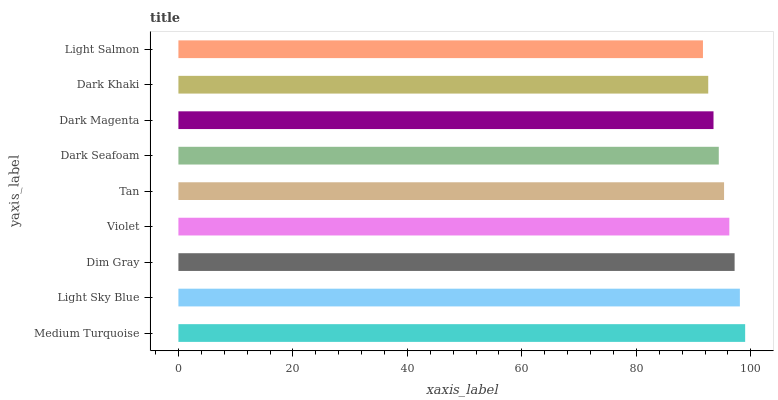Is Light Salmon the minimum?
Answer yes or no. Yes. Is Medium Turquoise the maximum?
Answer yes or no. Yes. Is Light Sky Blue the minimum?
Answer yes or no. No. Is Light Sky Blue the maximum?
Answer yes or no. No. Is Medium Turquoise greater than Light Sky Blue?
Answer yes or no. Yes. Is Light Sky Blue less than Medium Turquoise?
Answer yes or no. Yes. Is Light Sky Blue greater than Medium Turquoise?
Answer yes or no. No. Is Medium Turquoise less than Light Sky Blue?
Answer yes or no. No. Is Tan the high median?
Answer yes or no. Yes. Is Tan the low median?
Answer yes or no. Yes. Is Dark Magenta the high median?
Answer yes or no. No. Is Light Sky Blue the low median?
Answer yes or no. No. 